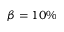Convert formula to latex. <formula><loc_0><loc_0><loc_500><loc_500>\beta = 1 0 \%</formula> 